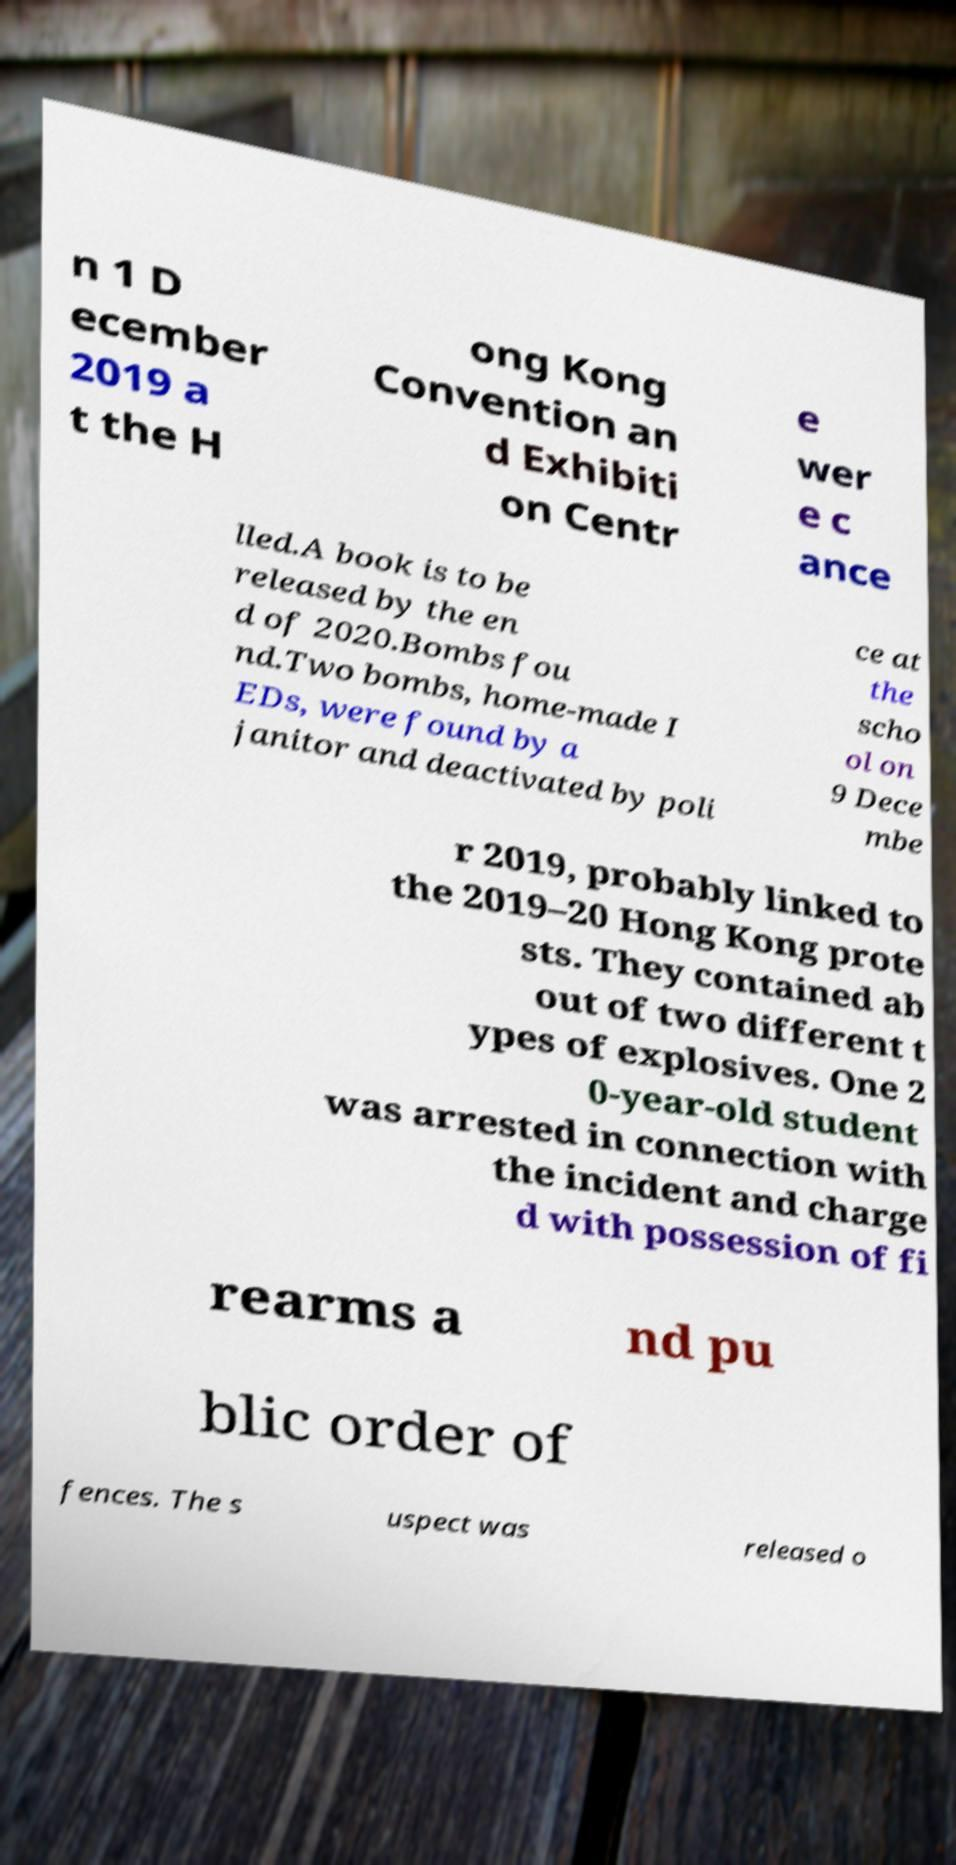Please read and relay the text visible in this image. What does it say? n 1 D ecember 2019 a t the H ong Kong Convention an d Exhibiti on Centr e wer e c ance lled.A book is to be released by the en d of 2020.Bombs fou nd.Two bombs, home-made I EDs, were found by a janitor and deactivated by poli ce at the scho ol on 9 Dece mbe r 2019, probably linked to the 2019–20 Hong Kong prote sts. They contained ab out of two different t ypes of explosives. One 2 0-year-old student was arrested in connection with the incident and charge d with possession of fi rearms a nd pu blic order of fences. The s uspect was released o 